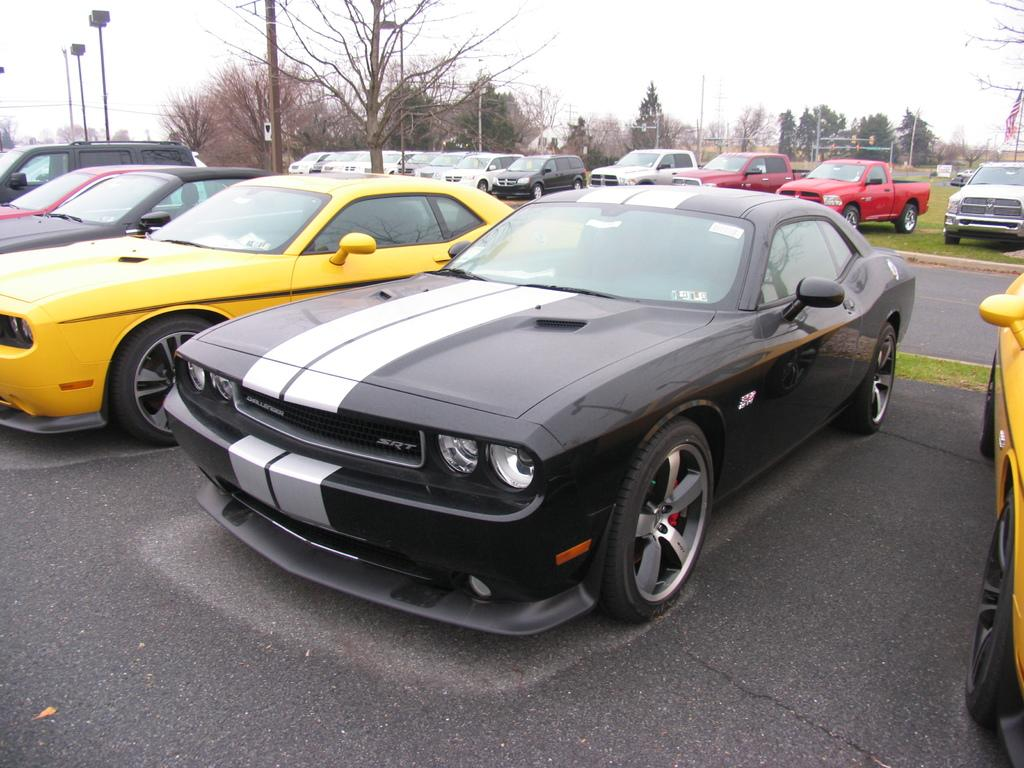What can be seen beside the road in the image? There are many cars parked beside the road. Are there any other objects or features between the parked cars? Yes, there are trees between the parked cars. Can you tell me how many pots are placed on the roof of the cars in the image? There are no pots visible on the roofs of the cars in the image. 